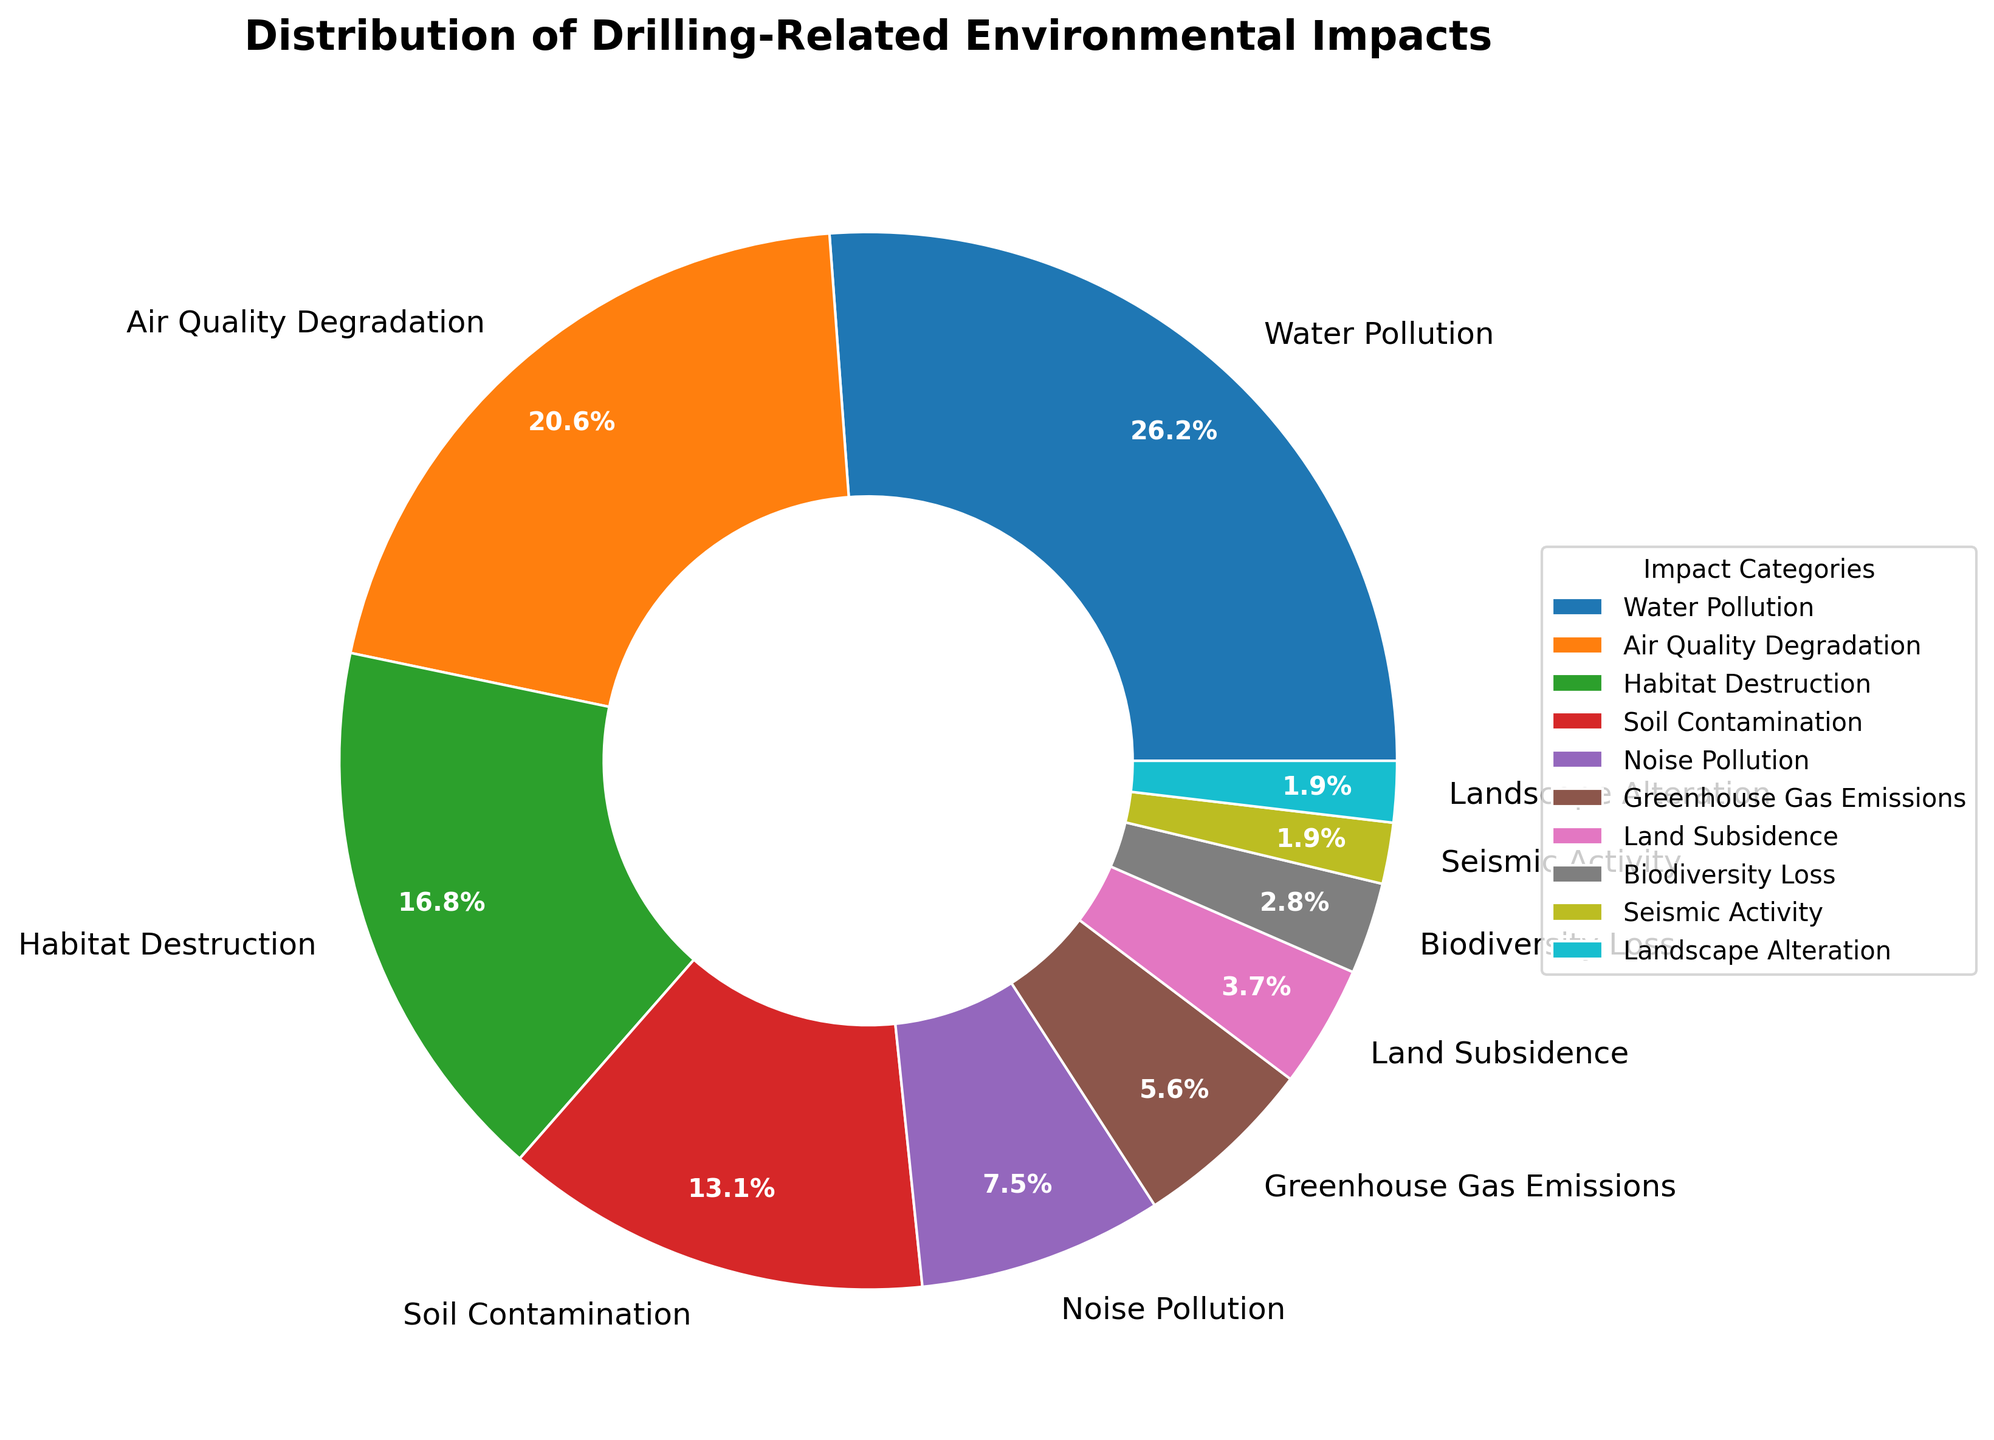What's the category with the highest impact percentage? The pie chart shows different categories with their corresponding percentages. The largest wedge represents Water Pollution with 28%.
Answer: Water Pollution Which two categories together make up over 50% of the impacts? Summing the largest percentages: Water Pollution (28%) and Air Quality Degradation (22%) gives 50%.
Answer: Water Pollution and Air Quality Degradation Which category contributes less to the impact, Landscape Alteration or Seismic Activity? Both percentages are given directly on the pie chart: Landscape Alteration is 2% and Seismic Activity is also 2%.
Answer: They contribute equally How many categories have an impact of more than 10%? From the pie chart, the categories are: Water Pollution (28%), Air Quality Degradation (22%), Habitat Destruction (18%), Soil Contamination (14%). That makes 4 categories.
Answer: 4 categories What is the combined percentage of the three smallest impact categories? Summing the smallest percentages: Biodiversity Loss (3%), Seismic Activity (2%), Landscape Alteration (2%) gives 7%.
Answer: 7% Which category is depicted in green color and what is its impact percentage? The wedge representing Soil Contamination appears green on the pie chart. Its percentage is 14%.
Answer: Soil Contamination with 14% Compare the percentages of Soil Contamination and Noise Pollution. Which one is higher? The percentage for Soil Contamination is 14%, while for Noise Pollution, it is 8%. So, Soil Contamination is higher.
Answer: Soil Contamination What is the difference in percentage between Air Quality Degradation and Greenhouse Gas Emissions? Air Quality Degradation is 22% and Greenhouse Gas Emissions is 6%. Subtracting these gives 16%.
Answer: 16% Which category has an 8% impact and what is its color? The pie chart shows Noise Pollution as having an 8% impact and it is generally depicted in light brown.
Answer: Noise Pollution, light brown List all the categories that contribute less than 10% to the environmental impact. Categories with less than 10% include: Noise Pollution (8%), Greenhouse Gas Emissions (6%), Land Subsidence (4%), Biodiversity Loss (3%), Seismic Activity (2%), Landscape Alteration (2%).
Answer: Noise Pollution, Greenhouse Gas Emissions, Land Subsidence, Biodiversity Loss, Seismic Activity, Landscape Alteration 